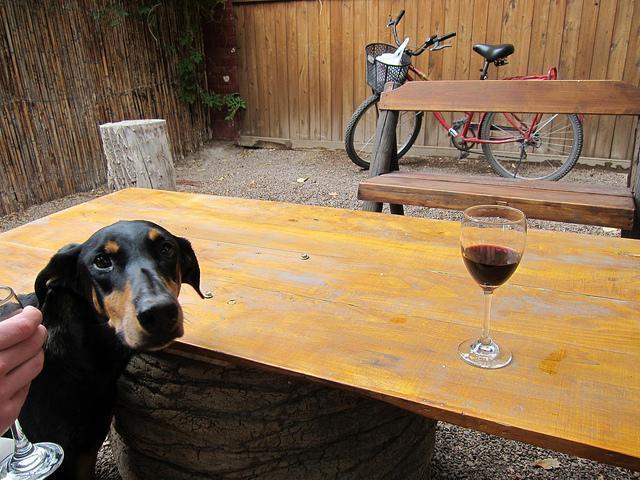How many bicycles are there?
Give a very brief answer. 1. How many wine glasses are there?
Give a very brief answer. 2. 